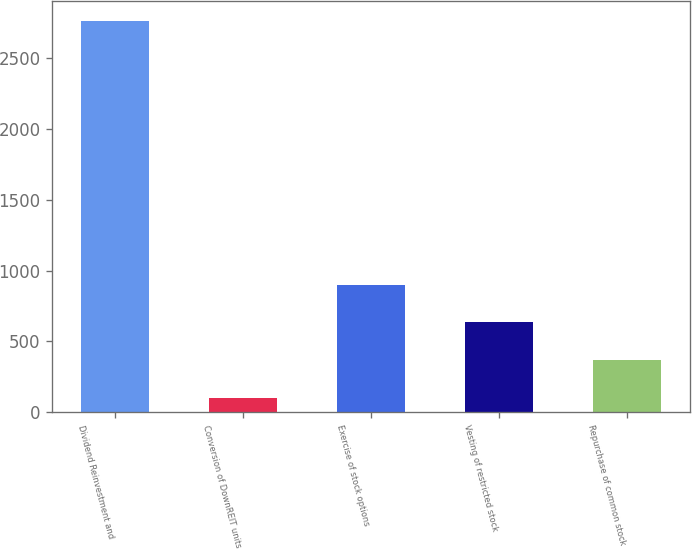Convert chart to OTSL. <chart><loc_0><loc_0><loc_500><loc_500><bar_chart><fcel>Dividend Reinvestment and<fcel>Conversion of DownREIT units<fcel>Exercise of stock options<fcel>Vesting of restricted stock<fcel>Repurchase of common stock<nl><fcel>2762<fcel>104<fcel>901.4<fcel>635.6<fcel>369.8<nl></chart> 